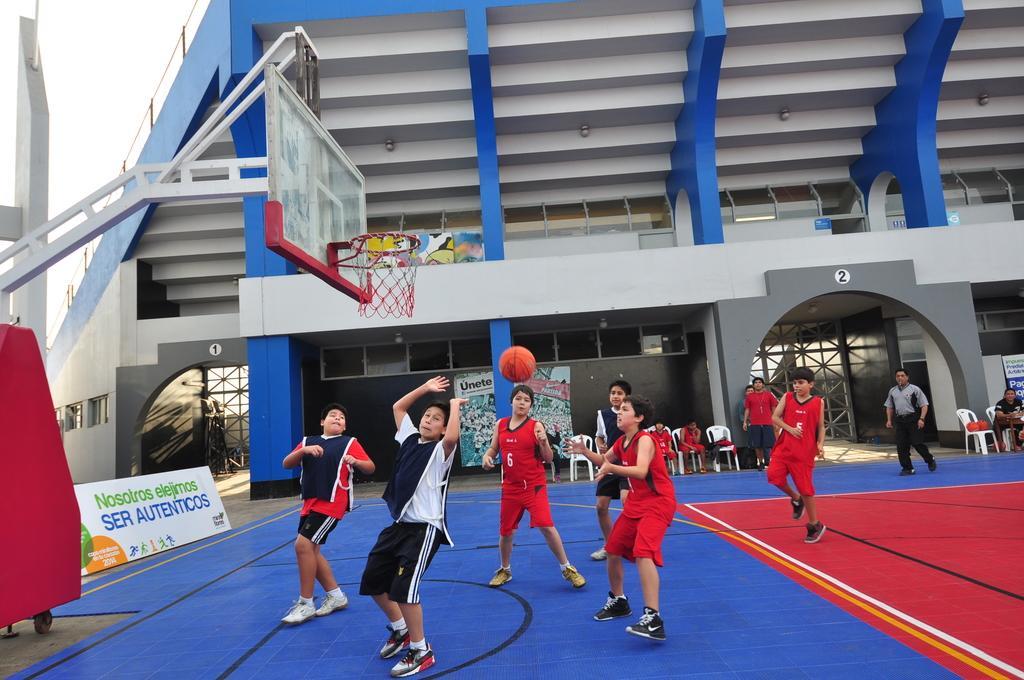Describe this image in one or two sentences. There are few persons playing on the ground. Here we can see boards, chairs, basketball goal, and a building. This is sky. 